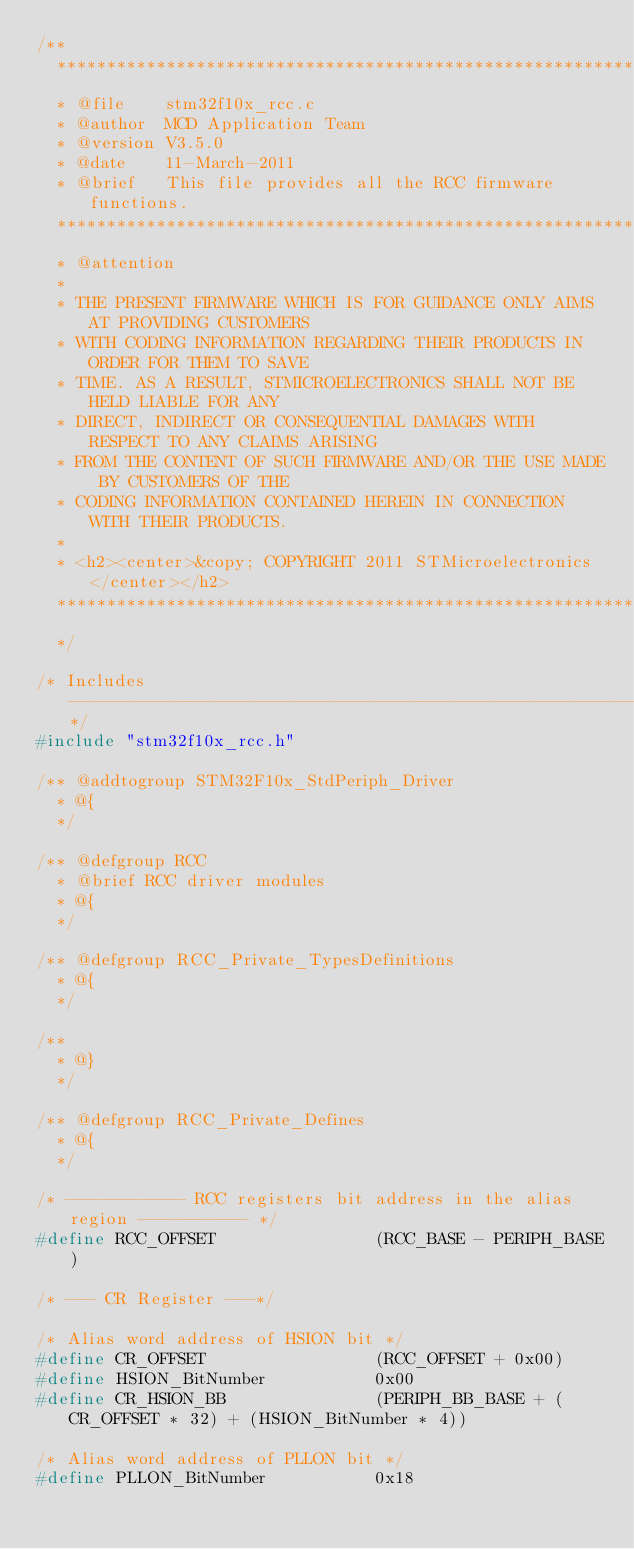Convert code to text. <code><loc_0><loc_0><loc_500><loc_500><_C_>/**
  ******************************************************************************
  * @file    stm32f10x_rcc.c
  * @author  MCD Application Team
  * @version V3.5.0
  * @date    11-March-2011
  * @brief   This file provides all the RCC firmware functions.
  ******************************************************************************
  * @attention
  *
  * THE PRESENT FIRMWARE WHICH IS FOR GUIDANCE ONLY AIMS AT PROVIDING CUSTOMERS
  * WITH CODING INFORMATION REGARDING THEIR PRODUCTS IN ORDER FOR THEM TO SAVE
  * TIME. AS A RESULT, STMICROELECTRONICS SHALL NOT BE HELD LIABLE FOR ANY
  * DIRECT, INDIRECT OR CONSEQUENTIAL DAMAGES WITH RESPECT TO ANY CLAIMS ARISING
  * FROM THE CONTENT OF SUCH FIRMWARE AND/OR THE USE MADE BY CUSTOMERS OF THE
  * CODING INFORMATION CONTAINED HEREIN IN CONNECTION WITH THEIR PRODUCTS.
  *
  * <h2><center>&copy; COPYRIGHT 2011 STMicroelectronics</center></h2>
  ******************************************************************************
  */

/* Includes ------------------------------------------------------------------*/
#include "stm32f10x_rcc.h"

/** @addtogroup STM32F10x_StdPeriph_Driver
  * @{
  */

/** @defgroup RCC
  * @brief RCC driver modules
  * @{
  */

/** @defgroup RCC_Private_TypesDefinitions
  * @{
  */

/**
  * @}
  */

/** @defgroup RCC_Private_Defines
  * @{
  */

/* ------------ RCC registers bit address in the alias region ----------- */
#define RCC_OFFSET                (RCC_BASE - PERIPH_BASE)

/* --- CR Register ---*/

/* Alias word address of HSION bit */
#define CR_OFFSET                 (RCC_OFFSET + 0x00)
#define HSION_BitNumber           0x00
#define CR_HSION_BB               (PERIPH_BB_BASE + (CR_OFFSET * 32) + (HSION_BitNumber * 4))

/* Alias word address of PLLON bit */
#define PLLON_BitNumber           0x18</code> 